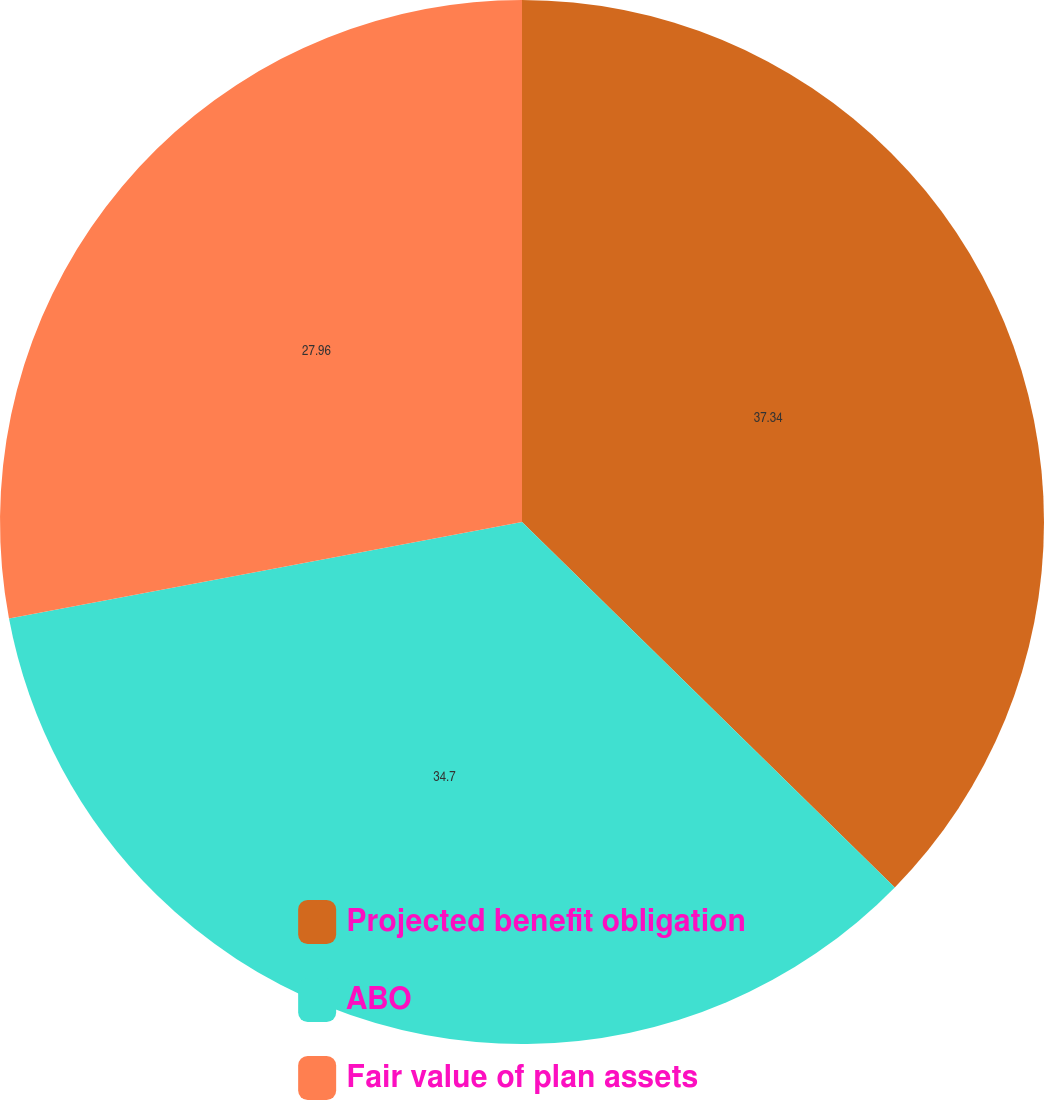Convert chart to OTSL. <chart><loc_0><loc_0><loc_500><loc_500><pie_chart><fcel>Projected benefit obligation<fcel>ABO<fcel>Fair value of plan assets<nl><fcel>37.34%<fcel>34.7%<fcel>27.96%<nl></chart> 